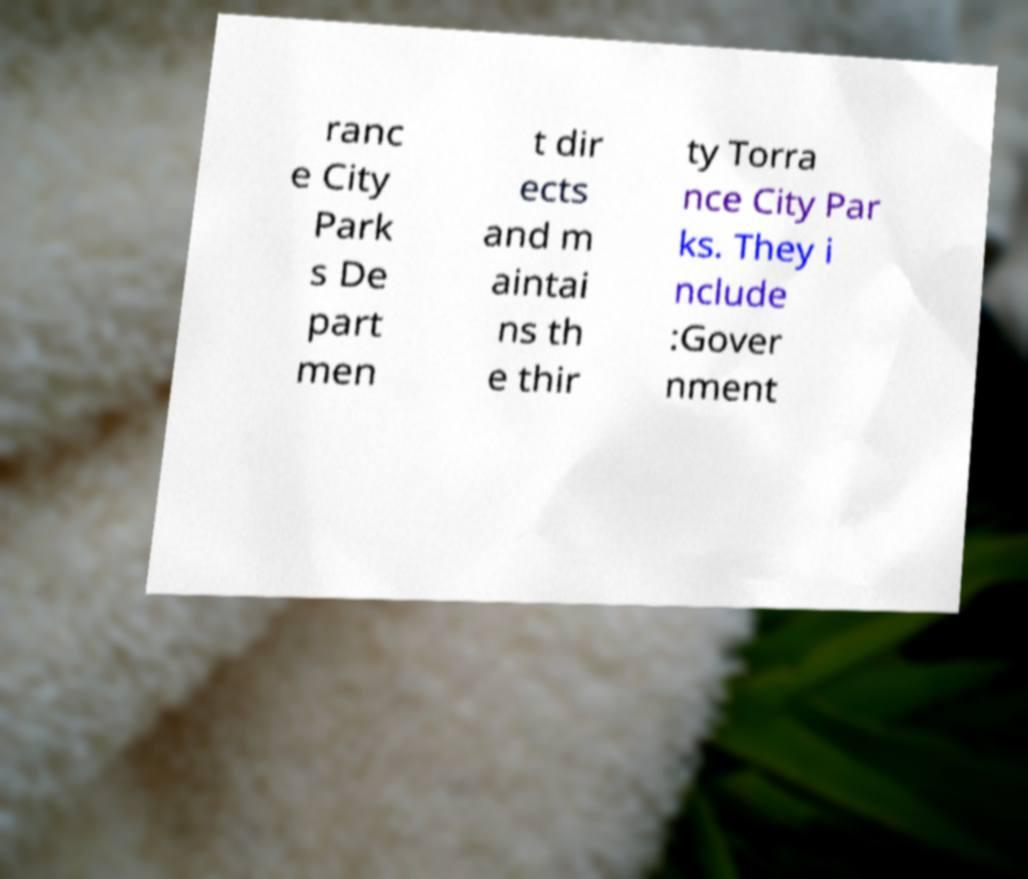Can you read and provide the text displayed in the image?This photo seems to have some interesting text. Can you extract and type it out for me? ranc e City Park s De part men t dir ects and m aintai ns th e thir ty Torra nce City Par ks. They i nclude :Gover nment 